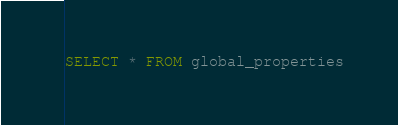<code> <loc_0><loc_0><loc_500><loc_500><_SQL_>SELECT * FROM global_properties</code> 